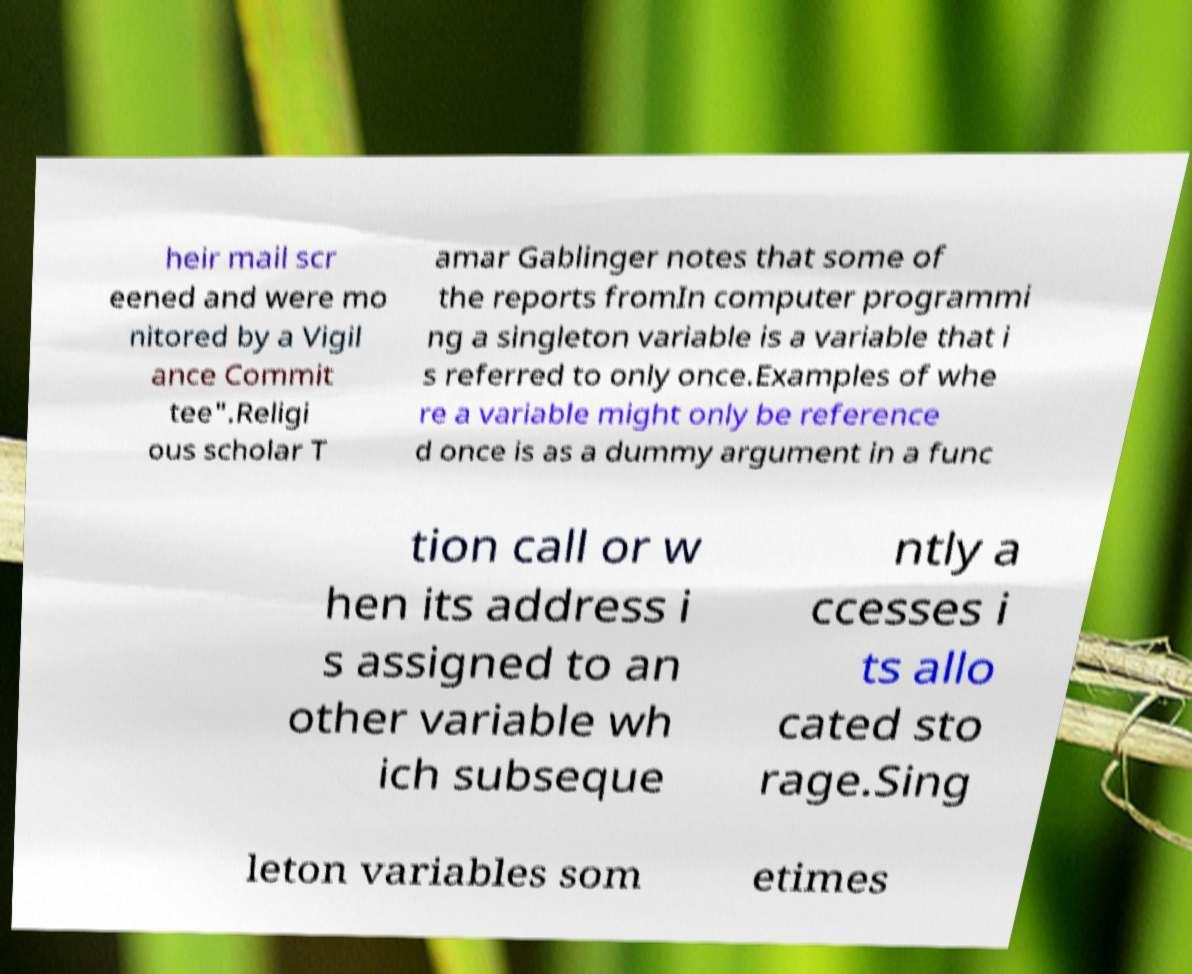I need the written content from this picture converted into text. Can you do that? heir mail scr eened and were mo nitored by a Vigil ance Commit tee".Religi ous scholar T amar Gablinger notes that some of the reports fromIn computer programmi ng a singleton variable is a variable that i s referred to only once.Examples of whe re a variable might only be reference d once is as a dummy argument in a func tion call or w hen its address i s assigned to an other variable wh ich subseque ntly a ccesses i ts allo cated sto rage.Sing leton variables som etimes 